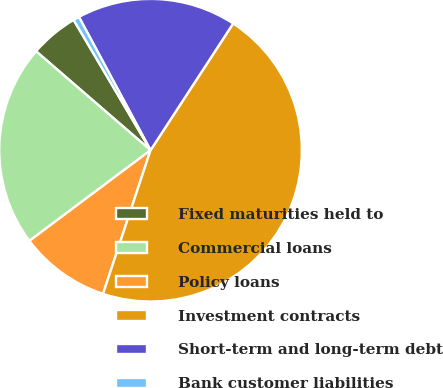Convert chart. <chart><loc_0><loc_0><loc_500><loc_500><pie_chart><fcel>Fixed maturities held to<fcel>Commercial loans<fcel>Policy loans<fcel>Investment contracts<fcel>Short-term and long-term debt<fcel>Bank customer liabilities<nl><fcel>5.17%<fcel>21.57%<fcel>9.69%<fcel>45.89%<fcel>17.04%<fcel>0.64%<nl></chart> 